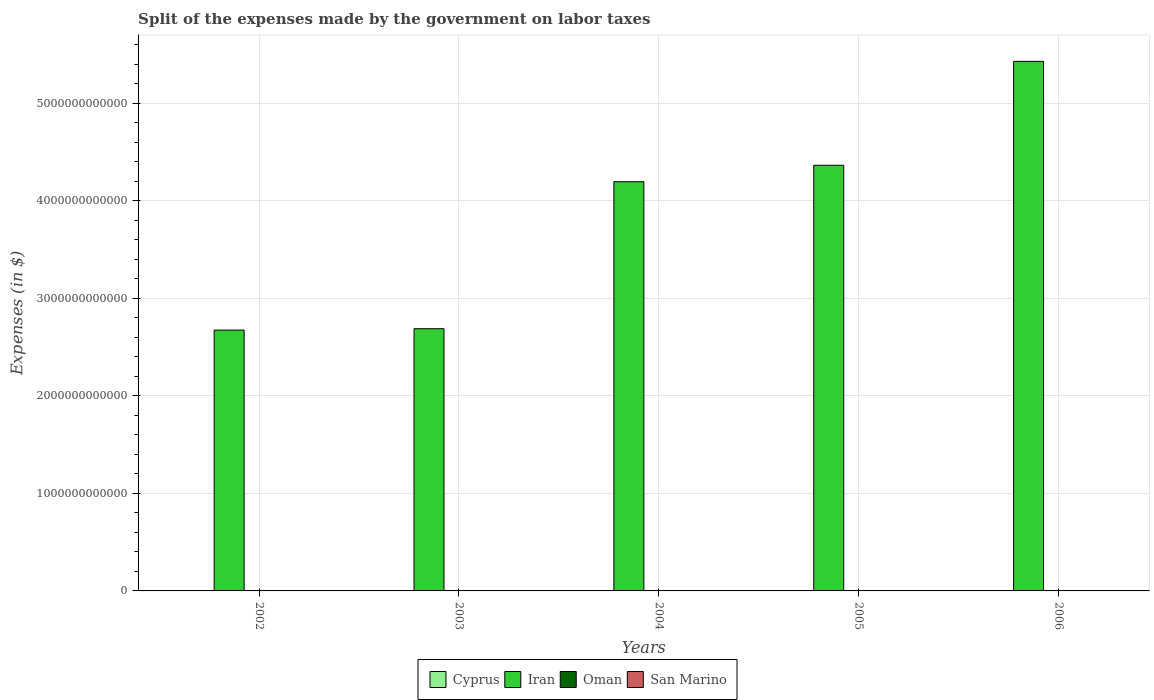How many different coloured bars are there?
Keep it short and to the point. 4. How many groups of bars are there?
Your answer should be very brief. 5. Are the number of bars per tick equal to the number of legend labels?
Offer a very short reply. Yes. Are the number of bars on each tick of the X-axis equal?
Offer a very short reply. Yes. What is the label of the 5th group of bars from the left?
Give a very brief answer. 2006. What is the expenses made by the government on labor taxes in Oman in 2002?
Keep it short and to the point. 3.98e+07. Across all years, what is the maximum expenses made by the government on labor taxes in Oman?
Provide a succinct answer. 7.82e+07. Across all years, what is the minimum expenses made by the government on labor taxes in San Marino?
Ensure brevity in your answer.  1.16e+07. What is the total expenses made by the government on labor taxes in Oman in the graph?
Your answer should be very brief. 2.81e+08. What is the difference between the expenses made by the government on labor taxes in Cyprus in 2005 and that in 2006?
Make the answer very short. 8.73e+07. What is the difference between the expenses made by the government on labor taxes in Iran in 2006 and the expenses made by the government on labor taxes in Oman in 2002?
Keep it short and to the point. 5.43e+12. What is the average expenses made by the government on labor taxes in Iran per year?
Offer a very short reply. 3.87e+12. In the year 2002, what is the difference between the expenses made by the government on labor taxes in Iran and expenses made by the government on labor taxes in Cyprus?
Provide a succinct answer. 2.67e+12. In how many years, is the expenses made by the government on labor taxes in Iran greater than 5400000000000 $?
Your answer should be very brief. 1. What is the ratio of the expenses made by the government on labor taxes in Cyprus in 2002 to that in 2005?
Provide a succinct answer. 0.25. Is the difference between the expenses made by the government on labor taxes in Iran in 2003 and 2005 greater than the difference between the expenses made by the government on labor taxes in Cyprus in 2003 and 2005?
Provide a succinct answer. No. What is the difference between the highest and the second highest expenses made by the government on labor taxes in Iran?
Provide a short and direct response. 1.07e+12. What is the difference between the highest and the lowest expenses made by the government on labor taxes in Iran?
Ensure brevity in your answer.  2.75e+12. In how many years, is the expenses made by the government on labor taxes in Oman greater than the average expenses made by the government on labor taxes in Oman taken over all years?
Make the answer very short. 2. Is the sum of the expenses made by the government on labor taxes in Iran in 2002 and 2006 greater than the maximum expenses made by the government on labor taxes in Oman across all years?
Provide a short and direct response. Yes. What does the 4th bar from the left in 2006 represents?
Offer a terse response. San Marino. What does the 4th bar from the right in 2006 represents?
Make the answer very short. Cyprus. Is it the case that in every year, the sum of the expenses made by the government on labor taxes in Oman and expenses made by the government on labor taxes in Iran is greater than the expenses made by the government on labor taxes in San Marino?
Your answer should be very brief. Yes. What is the difference between two consecutive major ticks on the Y-axis?
Keep it short and to the point. 1.00e+12. Are the values on the major ticks of Y-axis written in scientific E-notation?
Keep it short and to the point. No. How many legend labels are there?
Keep it short and to the point. 4. How are the legend labels stacked?
Ensure brevity in your answer.  Horizontal. What is the title of the graph?
Provide a succinct answer. Split of the expenses made by the government on labor taxes. What is the label or title of the X-axis?
Your response must be concise. Years. What is the label or title of the Y-axis?
Make the answer very short. Expenses (in $). What is the Expenses (in $) of Cyprus in 2002?
Ensure brevity in your answer.  1.40e+08. What is the Expenses (in $) in Iran in 2002?
Offer a very short reply. 2.67e+12. What is the Expenses (in $) of Oman in 2002?
Your answer should be compact. 3.98e+07. What is the Expenses (in $) of San Marino in 2002?
Make the answer very short. 1.16e+07. What is the Expenses (in $) of Cyprus in 2003?
Your answer should be compact. 2.93e+08. What is the Expenses (in $) of Iran in 2003?
Your answer should be very brief. 2.69e+12. What is the Expenses (in $) in Oman in 2003?
Ensure brevity in your answer.  4.31e+07. What is the Expenses (in $) in San Marino in 2003?
Provide a short and direct response. 1.21e+07. What is the Expenses (in $) of Cyprus in 2004?
Your answer should be compact. 4.89e+08. What is the Expenses (in $) in Iran in 2004?
Provide a succinct answer. 4.19e+12. What is the Expenses (in $) in Oman in 2004?
Give a very brief answer. 4.91e+07. What is the Expenses (in $) of San Marino in 2004?
Offer a terse response. 1.28e+07. What is the Expenses (in $) of Cyprus in 2005?
Offer a very short reply. 5.71e+08. What is the Expenses (in $) of Iran in 2005?
Provide a succinct answer. 4.36e+12. What is the Expenses (in $) in Oman in 2005?
Offer a terse response. 7.12e+07. What is the Expenses (in $) of San Marino in 2005?
Your response must be concise. 1.40e+07. What is the Expenses (in $) of Cyprus in 2006?
Give a very brief answer. 4.84e+08. What is the Expenses (in $) in Iran in 2006?
Your answer should be compact. 5.43e+12. What is the Expenses (in $) in Oman in 2006?
Your answer should be very brief. 7.82e+07. What is the Expenses (in $) of San Marino in 2006?
Keep it short and to the point. 2.84e+07. Across all years, what is the maximum Expenses (in $) in Cyprus?
Provide a succinct answer. 5.71e+08. Across all years, what is the maximum Expenses (in $) in Iran?
Your answer should be compact. 5.43e+12. Across all years, what is the maximum Expenses (in $) in Oman?
Offer a terse response. 7.82e+07. Across all years, what is the maximum Expenses (in $) in San Marino?
Keep it short and to the point. 2.84e+07. Across all years, what is the minimum Expenses (in $) of Cyprus?
Offer a very short reply. 1.40e+08. Across all years, what is the minimum Expenses (in $) in Iran?
Your answer should be compact. 2.67e+12. Across all years, what is the minimum Expenses (in $) in Oman?
Ensure brevity in your answer.  3.98e+07. Across all years, what is the minimum Expenses (in $) in San Marino?
Give a very brief answer. 1.16e+07. What is the total Expenses (in $) of Cyprus in the graph?
Give a very brief answer. 1.98e+09. What is the total Expenses (in $) in Iran in the graph?
Offer a very short reply. 1.93e+13. What is the total Expenses (in $) in Oman in the graph?
Ensure brevity in your answer.  2.81e+08. What is the total Expenses (in $) of San Marino in the graph?
Provide a short and direct response. 7.89e+07. What is the difference between the Expenses (in $) of Cyprus in 2002 and that in 2003?
Your response must be concise. -1.53e+08. What is the difference between the Expenses (in $) in Iran in 2002 and that in 2003?
Offer a very short reply. -1.43e+1. What is the difference between the Expenses (in $) of Oman in 2002 and that in 2003?
Offer a terse response. -3.30e+06. What is the difference between the Expenses (in $) of San Marino in 2002 and that in 2003?
Offer a very short reply. -5.42e+05. What is the difference between the Expenses (in $) of Cyprus in 2002 and that in 2004?
Offer a terse response. -3.49e+08. What is the difference between the Expenses (in $) of Iran in 2002 and that in 2004?
Provide a succinct answer. -1.52e+12. What is the difference between the Expenses (in $) of Oman in 2002 and that in 2004?
Your answer should be very brief. -9.30e+06. What is the difference between the Expenses (in $) in San Marino in 2002 and that in 2004?
Your answer should be very brief. -1.24e+06. What is the difference between the Expenses (in $) of Cyprus in 2002 and that in 2005?
Give a very brief answer. -4.30e+08. What is the difference between the Expenses (in $) of Iran in 2002 and that in 2005?
Keep it short and to the point. -1.69e+12. What is the difference between the Expenses (in $) in Oman in 2002 and that in 2005?
Make the answer very short. -3.14e+07. What is the difference between the Expenses (in $) of San Marino in 2002 and that in 2005?
Make the answer very short. -2.44e+06. What is the difference between the Expenses (in $) in Cyprus in 2002 and that in 2006?
Ensure brevity in your answer.  -3.43e+08. What is the difference between the Expenses (in $) of Iran in 2002 and that in 2006?
Your answer should be very brief. -2.75e+12. What is the difference between the Expenses (in $) of Oman in 2002 and that in 2006?
Offer a terse response. -3.84e+07. What is the difference between the Expenses (in $) of San Marino in 2002 and that in 2006?
Keep it short and to the point. -1.69e+07. What is the difference between the Expenses (in $) in Cyprus in 2003 and that in 2004?
Your response must be concise. -1.96e+08. What is the difference between the Expenses (in $) in Iran in 2003 and that in 2004?
Ensure brevity in your answer.  -1.51e+12. What is the difference between the Expenses (in $) in Oman in 2003 and that in 2004?
Your answer should be compact. -6.00e+06. What is the difference between the Expenses (in $) in San Marino in 2003 and that in 2004?
Your answer should be compact. -7.01e+05. What is the difference between the Expenses (in $) in Cyprus in 2003 and that in 2005?
Your answer should be compact. -2.77e+08. What is the difference between the Expenses (in $) in Iran in 2003 and that in 2005?
Keep it short and to the point. -1.68e+12. What is the difference between the Expenses (in $) in Oman in 2003 and that in 2005?
Your response must be concise. -2.81e+07. What is the difference between the Expenses (in $) of San Marino in 2003 and that in 2005?
Provide a succinct answer. -1.90e+06. What is the difference between the Expenses (in $) of Cyprus in 2003 and that in 2006?
Offer a terse response. -1.90e+08. What is the difference between the Expenses (in $) of Iran in 2003 and that in 2006?
Provide a succinct answer. -2.74e+12. What is the difference between the Expenses (in $) of Oman in 2003 and that in 2006?
Keep it short and to the point. -3.51e+07. What is the difference between the Expenses (in $) of San Marino in 2003 and that in 2006?
Your response must be concise. -1.63e+07. What is the difference between the Expenses (in $) of Cyprus in 2004 and that in 2005?
Make the answer very short. -8.18e+07. What is the difference between the Expenses (in $) of Iran in 2004 and that in 2005?
Offer a terse response. -1.68e+11. What is the difference between the Expenses (in $) of Oman in 2004 and that in 2005?
Keep it short and to the point. -2.21e+07. What is the difference between the Expenses (in $) in San Marino in 2004 and that in 2005?
Your answer should be very brief. -1.20e+06. What is the difference between the Expenses (in $) of Cyprus in 2004 and that in 2006?
Offer a very short reply. 5.47e+06. What is the difference between the Expenses (in $) of Iran in 2004 and that in 2006?
Your response must be concise. -1.23e+12. What is the difference between the Expenses (in $) of Oman in 2004 and that in 2006?
Provide a succinct answer. -2.91e+07. What is the difference between the Expenses (in $) of San Marino in 2004 and that in 2006?
Your answer should be very brief. -1.56e+07. What is the difference between the Expenses (in $) of Cyprus in 2005 and that in 2006?
Keep it short and to the point. 8.73e+07. What is the difference between the Expenses (in $) in Iran in 2005 and that in 2006?
Your answer should be very brief. -1.07e+12. What is the difference between the Expenses (in $) in Oman in 2005 and that in 2006?
Your response must be concise. -7.00e+06. What is the difference between the Expenses (in $) in San Marino in 2005 and that in 2006?
Provide a succinct answer. -1.44e+07. What is the difference between the Expenses (in $) in Cyprus in 2002 and the Expenses (in $) in Iran in 2003?
Offer a terse response. -2.69e+12. What is the difference between the Expenses (in $) in Cyprus in 2002 and the Expenses (in $) in Oman in 2003?
Give a very brief answer. 9.73e+07. What is the difference between the Expenses (in $) in Cyprus in 2002 and the Expenses (in $) in San Marino in 2003?
Offer a very short reply. 1.28e+08. What is the difference between the Expenses (in $) of Iran in 2002 and the Expenses (in $) of Oman in 2003?
Provide a short and direct response. 2.67e+12. What is the difference between the Expenses (in $) in Iran in 2002 and the Expenses (in $) in San Marino in 2003?
Ensure brevity in your answer.  2.67e+12. What is the difference between the Expenses (in $) of Oman in 2002 and the Expenses (in $) of San Marino in 2003?
Ensure brevity in your answer.  2.77e+07. What is the difference between the Expenses (in $) of Cyprus in 2002 and the Expenses (in $) of Iran in 2004?
Keep it short and to the point. -4.19e+12. What is the difference between the Expenses (in $) in Cyprus in 2002 and the Expenses (in $) in Oman in 2004?
Make the answer very short. 9.13e+07. What is the difference between the Expenses (in $) of Cyprus in 2002 and the Expenses (in $) of San Marino in 2004?
Your answer should be compact. 1.28e+08. What is the difference between the Expenses (in $) in Iran in 2002 and the Expenses (in $) in Oman in 2004?
Offer a very short reply. 2.67e+12. What is the difference between the Expenses (in $) in Iran in 2002 and the Expenses (in $) in San Marino in 2004?
Offer a terse response. 2.67e+12. What is the difference between the Expenses (in $) in Oman in 2002 and the Expenses (in $) in San Marino in 2004?
Your response must be concise. 2.70e+07. What is the difference between the Expenses (in $) in Cyprus in 2002 and the Expenses (in $) in Iran in 2005?
Your answer should be very brief. -4.36e+12. What is the difference between the Expenses (in $) of Cyprus in 2002 and the Expenses (in $) of Oman in 2005?
Offer a very short reply. 6.92e+07. What is the difference between the Expenses (in $) of Cyprus in 2002 and the Expenses (in $) of San Marino in 2005?
Ensure brevity in your answer.  1.26e+08. What is the difference between the Expenses (in $) in Iran in 2002 and the Expenses (in $) in Oman in 2005?
Offer a terse response. 2.67e+12. What is the difference between the Expenses (in $) in Iran in 2002 and the Expenses (in $) in San Marino in 2005?
Keep it short and to the point. 2.67e+12. What is the difference between the Expenses (in $) of Oman in 2002 and the Expenses (in $) of San Marino in 2005?
Provide a short and direct response. 2.58e+07. What is the difference between the Expenses (in $) of Cyprus in 2002 and the Expenses (in $) of Iran in 2006?
Your answer should be very brief. -5.43e+12. What is the difference between the Expenses (in $) in Cyprus in 2002 and the Expenses (in $) in Oman in 2006?
Give a very brief answer. 6.22e+07. What is the difference between the Expenses (in $) of Cyprus in 2002 and the Expenses (in $) of San Marino in 2006?
Offer a terse response. 1.12e+08. What is the difference between the Expenses (in $) of Iran in 2002 and the Expenses (in $) of Oman in 2006?
Your response must be concise. 2.67e+12. What is the difference between the Expenses (in $) in Iran in 2002 and the Expenses (in $) in San Marino in 2006?
Your answer should be compact. 2.67e+12. What is the difference between the Expenses (in $) of Oman in 2002 and the Expenses (in $) of San Marino in 2006?
Keep it short and to the point. 1.14e+07. What is the difference between the Expenses (in $) of Cyprus in 2003 and the Expenses (in $) of Iran in 2004?
Provide a succinct answer. -4.19e+12. What is the difference between the Expenses (in $) in Cyprus in 2003 and the Expenses (in $) in Oman in 2004?
Your response must be concise. 2.44e+08. What is the difference between the Expenses (in $) in Cyprus in 2003 and the Expenses (in $) in San Marino in 2004?
Your response must be concise. 2.81e+08. What is the difference between the Expenses (in $) of Iran in 2003 and the Expenses (in $) of Oman in 2004?
Ensure brevity in your answer.  2.69e+12. What is the difference between the Expenses (in $) of Iran in 2003 and the Expenses (in $) of San Marino in 2004?
Keep it short and to the point. 2.69e+12. What is the difference between the Expenses (in $) in Oman in 2003 and the Expenses (in $) in San Marino in 2004?
Make the answer very short. 3.03e+07. What is the difference between the Expenses (in $) in Cyprus in 2003 and the Expenses (in $) in Iran in 2005?
Offer a terse response. -4.36e+12. What is the difference between the Expenses (in $) in Cyprus in 2003 and the Expenses (in $) in Oman in 2005?
Your answer should be compact. 2.22e+08. What is the difference between the Expenses (in $) in Cyprus in 2003 and the Expenses (in $) in San Marino in 2005?
Ensure brevity in your answer.  2.79e+08. What is the difference between the Expenses (in $) in Iran in 2003 and the Expenses (in $) in Oman in 2005?
Offer a very short reply. 2.69e+12. What is the difference between the Expenses (in $) of Iran in 2003 and the Expenses (in $) of San Marino in 2005?
Offer a terse response. 2.69e+12. What is the difference between the Expenses (in $) in Oman in 2003 and the Expenses (in $) in San Marino in 2005?
Offer a terse response. 2.91e+07. What is the difference between the Expenses (in $) in Cyprus in 2003 and the Expenses (in $) in Iran in 2006?
Offer a terse response. -5.43e+12. What is the difference between the Expenses (in $) in Cyprus in 2003 and the Expenses (in $) in Oman in 2006?
Provide a short and direct response. 2.15e+08. What is the difference between the Expenses (in $) of Cyprus in 2003 and the Expenses (in $) of San Marino in 2006?
Provide a short and direct response. 2.65e+08. What is the difference between the Expenses (in $) of Iran in 2003 and the Expenses (in $) of Oman in 2006?
Ensure brevity in your answer.  2.69e+12. What is the difference between the Expenses (in $) of Iran in 2003 and the Expenses (in $) of San Marino in 2006?
Offer a very short reply. 2.69e+12. What is the difference between the Expenses (in $) of Oman in 2003 and the Expenses (in $) of San Marino in 2006?
Provide a short and direct response. 1.47e+07. What is the difference between the Expenses (in $) in Cyprus in 2004 and the Expenses (in $) in Iran in 2005?
Make the answer very short. -4.36e+12. What is the difference between the Expenses (in $) of Cyprus in 2004 and the Expenses (in $) of Oman in 2005?
Make the answer very short. 4.18e+08. What is the difference between the Expenses (in $) of Cyprus in 2004 and the Expenses (in $) of San Marino in 2005?
Ensure brevity in your answer.  4.75e+08. What is the difference between the Expenses (in $) of Iran in 2004 and the Expenses (in $) of Oman in 2005?
Make the answer very short. 4.19e+12. What is the difference between the Expenses (in $) of Iran in 2004 and the Expenses (in $) of San Marino in 2005?
Your answer should be very brief. 4.19e+12. What is the difference between the Expenses (in $) of Oman in 2004 and the Expenses (in $) of San Marino in 2005?
Offer a very short reply. 3.51e+07. What is the difference between the Expenses (in $) of Cyprus in 2004 and the Expenses (in $) of Iran in 2006?
Make the answer very short. -5.43e+12. What is the difference between the Expenses (in $) of Cyprus in 2004 and the Expenses (in $) of Oman in 2006?
Keep it short and to the point. 4.11e+08. What is the difference between the Expenses (in $) in Cyprus in 2004 and the Expenses (in $) in San Marino in 2006?
Ensure brevity in your answer.  4.61e+08. What is the difference between the Expenses (in $) of Iran in 2004 and the Expenses (in $) of Oman in 2006?
Provide a succinct answer. 4.19e+12. What is the difference between the Expenses (in $) of Iran in 2004 and the Expenses (in $) of San Marino in 2006?
Your answer should be very brief. 4.19e+12. What is the difference between the Expenses (in $) in Oman in 2004 and the Expenses (in $) in San Marino in 2006?
Your response must be concise. 2.07e+07. What is the difference between the Expenses (in $) of Cyprus in 2005 and the Expenses (in $) of Iran in 2006?
Offer a very short reply. -5.43e+12. What is the difference between the Expenses (in $) in Cyprus in 2005 and the Expenses (in $) in Oman in 2006?
Keep it short and to the point. 4.93e+08. What is the difference between the Expenses (in $) in Cyprus in 2005 and the Expenses (in $) in San Marino in 2006?
Give a very brief answer. 5.42e+08. What is the difference between the Expenses (in $) of Iran in 2005 and the Expenses (in $) of Oman in 2006?
Provide a succinct answer. 4.36e+12. What is the difference between the Expenses (in $) of Iran in 2005 and the Expenses (in $) of San Marino in 2006?
Offer a very short reply. 4.36e+12. What is the difference between the Expenses (in $) in Oman in 2005 and the Expenses (in $) in San Marino in 2006?
Keep it short and to the point. 4.28e+07. What is the average Expenses (in $) in Cyprus per year?
Provide a short and direct response. 3.95e+08. What is the average Expenses (in $) of Iran per year?
Keep it short and to the point. 3.87e+12. What is the average Expenses (in $) in Oman per year?
Keep it short and to the point. 5.63e+07. What is the average Expenses (in $) in San Marino per year?
Provide a short and direct response. 1.58e+07. In the year 2002, what is the difference between the Expenses (in $) in Cyprus and Expenses (in $) in Iran?
Ensure brevity in your answer.  -2.67e+12. In the year 2002, what is the difference between the Expenses (in $) in Cyprus and Expenses (in $) in Oman?
Provide a succinct answer. 1.01e+08. In the year 2002, what is the difference between the Expenses (in $) of Cyprus and Expenses (in $) of San Marino?
Your answer should be very brief. 1.29e+08. In the year 2002, what is the difference between the Expenses (in $) of Iran and Expenses (in $) of Oman?
Make the answer very short. 2.67e+12. In the year 2002, what is the difference between the Expenses (in $) in Iran and Expenses (in $) in San Marino?
Make the answer very short. 2.67e+12. In the year 2002, what is the difference between the Expenses (in $) of Oman and Expenses (in $) of San Marino?
Ensure brevity in your answer.  2.82e+07. In the year 2003, what is the difference between the Expenses (in $) of Cyprus and Expenses (in $) of Iran?
Your answer should be very brief. -2.69e+12. In the year 2003, what is the difference between the Expenses (in $) in Cyprus and Expenses (in $) in Oman?
Your answer should be compact. 2.50e+08. In the year 2003, what is the difference between the Expenses (in $) in Cyprus and Expenses (in $) in San Marino?
Your response must be concise. 2.81e+08. In the year 2003, what is the difference between the Expenses (in $) of Iran and Expenses (in $) of Oman?
Ensure brevity in your answer.  2.69e+12. In the year 2003, what is the difference between the Expenses (in $) of Iran and Expenses (in $) of San Marino?
Provide a succinct answer. 2.69e+12. In the year 2003, what is the difference between the Expenses (in $) of Oman and Expenses (in $) of San Marino?
Your answer should be very brief. 3.10e+07. In the year 2004, what is the difference between the Expenses (in $) of Cyprus and Expenses (in $) of Iran?
Your response must be concise. -4.19e+12. In the year 2004, what is the difference between the Expenses (in $) in Cyprus and Expenses (in $) in Oman?
Provide a succinct answer. 4.40e+08. In the year 2004, what is the difference between the Expenses (in $) of Cyprus and Expenses (in $) of San Marino?
Provide a succinct answer. 4.76e+08. In the year 2004, what is the difference between the Expenses (in $) in Iran and Expenses (in $) in Oman?
Your answer should be compact. 4.19e+12. In the year 2004, what is the difference between the Expenses (in $) of Iran and Expenses (in $) of San Marino?
Provide a short and direct response. 4.19e+12. In the year 2004, what is the difference between the Expenses (in $) in Oman and Expenses (in $) in San Marino?
Keep it short and to the point. 3.63e+07. In the year 2005, what is the difference between the Expenses (in $) of Cyprus and Expenses (in $) of Iran?
Provide a succinct answer. -4.36e+12. In the year 2005, what is the difference between the Expenses (in $) in Cyprus and Expenses (in $) in Oman?
Provide a succinct answer. 5.00e+08. In the year 2005, what is the difference between the Expenses (in $) of Cyprus and Expenses (in $) of San Marino?
Keep it short and to the point. 5.57e+08. In the year 2005, what is the difference between the Expenses (in $) in Iran and Expenses (in $) in Oman?
Provide a short and direct response. 4.36e+12. In the year 2005, what is the difference between the Expenses (in $) in Iran and Expenses (in $) in San Marino?
Your response must be concise. 4.36e+12. In the year 2005, what is the difference between the Expenses (in $) in Oman and Expenses (in $) in San Marino?
Give a very brief answer. 5.72e+07. In the year 2006, what is the difference between the Expenses (in $) of Cyprus and Expenses (in $) of Iran?
Your answer should be compact. -5.43e+12. In the year 2006, what is the difference between the Expenses (in $) of Cyprus and Expenses (in $) of Oman?
Keep it short and to the point. 4.05e+08. In the year 2006, what is the difference between the Expenses (in $) of Cyprus and Expenses (in $) of San Marino?
Provide a short and direct response. 4.55e+08. In the year 2006, what is the difference between the Expenses (in $) of Iran and Expenses (in $) of Oman?
Your response must be concise. 5.43e+12. In the year 2006, what is the difference between the Expenses (in $) in Iran and Expenses (in $) in San Marino?
Ensure brevity in your answer.  5.43e+12. In the year 2006, what is the difference between the Expenses (in $) of Oman and Expenses (in $) of San Marino?
Provide a succinct answer. 4.98e+07. What is the ratio of the Expenses (in $) in Cyprus in 2002 to that in 2003?
Offer a very short reply. 0.48. What is the ratio of the Expenses (in $) in Oman in 2002 to that in 2003?
Offer a very short reply. 0.92. What is the ratio of the Expenses (in $) of San Marino in 2002 to that in 2003?
Your answer should be compact. 0.96. What is the ratio of the Expenses (in $) in Cyprus in 2002 to that in 2004?
Ensure brevity in your answer.  0.29. What is the ratio of the Expenses (in $) of Iran in 2002 to that in 2004?
Ensure brevity in your answer.  0.64. What is the ratio of the Expenses (in $) in Oman in 2002 to that in 2004?
Offer a very short reply. 0.81. What is the ratio of the Expenses (in $) in San Marino in 2002 to that in 2004?
Your response must be concise. 0.9. What is the ratio of the Expenses (in $) in Cyprus in 2002 to that in 2005?
Ensure brevity in your answer.  0.25. What is the ratio of the Expenses (in $) in Iran in 2002 to that in 2005?
Offer a terse response. 0.61. What is the ratio of the Expenses (in $) of Oman in 2002 to that in 2005?
Provide a succinct answer. 0.56. What is the ratio of the Expenses (in $) of San Marino in 2002 to that in 2005?
Your response must be concise. 0.83. What is the ratio of the Expenses (in $) in Cyprus in 2002 to that in 2006?
Provide a short and direct response. 0.29. What is the ratio of the Expenses (in $) of Iran in 2002 to that in 2006?
Offer a very short reply. 0.49. What is the ratio of the Expenses (in $) in Oman in 2002 to that in 2006?
Your answer should be very brief. 0.51. What is the ratio of the Expenses (in $) of San Marino in 2002 to that in 2006?
Your answer should be compact. 0.41. What is the ratio of the Expenses (in $) in Cyprus in 2003 to that in 2004?
Your answer should be compact. 0.6. What is the ratio of the Expenses (in $) of Iran in 2003 to that in 2004?
Provide a succinct answer. 0.64. What is the ratio of the Expenses (in $) of Oman in 2003 to that in 2004?
Give a very brief answer. 0.88. What is the ratio of the Expenses (in $) of San Marino in 2003 to that in 2004?
Your response must be concise. 0.95. What is the ratio of the Expenses (in $) of Cyprus in 2003 to that in 2005?
Provide a short and direct response. 0.51. What is the ratio of the Expenses (in $) of Iran in 2003 to that in 2005?
Your answer should be compact. 0.62. What is the ratio of the Expenses (in $) of Oman in 2003 to that in 2005?
Provide a succinct answer. 0.61. What is the ratio of the Expenses (in $) of San Marino in 2003 to that in 2005?
Provide a short and direct response. 0.86. What is the ratio of the Expenses (in $) in Cyprus in 2003 to that in 2006?
Provide a succinct answer. 0.61. What is the ratio of the Expenses (in $) of Iran in 2003 to that in 2006?
Make the answer very short. 0.5. What is the ratio of the Expenses (in $) of Oman in 2003 to that in 2006?
Make the answer very short. 0.55. What is the ratio of the Expenses (in $) of San Marino in 2003 to that in 2006?
Your answer should be compact. 0.43. What is the ratio of the Expenses (in $) of Cyprus in 2004 to that in 2005?
Give a very brief answer. 0.86. What is the ratio of the Expenses (in $) of Iran in 2004 to that in 2005?
Your response must be concise. 0.96. What is the ratio of the Expenses (in $) of Oman in 2004 to that in 2005?
Make the answer very short. 0.69. What is the ratio of the Expenses (in $) of San Marino in 2004 to that in 2005?
Provide a short and direct response. 0.91. What is the ratio of the Expenses (in $) of Cyprus in 2004 to that in 2006?
Your answer should be compact. 1.01. What is the ratio of the Expenses (in $) of Iran in 2004 to that in 2006?
Ensure brevity in your answer.  0.77. What is the ratio of the Expenses (in $) of Oman in 2004 to that in 2006?
Ensure brevity in your answer.  0.63. What is the ratio of the Expenses (in $) in San Marino in 2004 to that in 2006?
Ensure brevity in your answer.  0.45. What is the ratio of the Expenses (in $) in Cyprus in 2005 to that in 2006?
Make the answer very short. 1.18. What is the ratio of the Expenses (in $) in Iran in 2005 to that in 2006?
Offer a very short reply. 0.8. What is the ratio of the Expenses (in $) in Oman in 2005 to that in 2006?
Your answer should be very brief. 0.91. What is the ratio of the Expenses (in $) in San Marino in 2005 to that in 2006?
Your answer should be very brief. 0.49. What is the difference between the highest and the second highest Expenses (in $) of Cyprus?
Provide a short and direct response. 8.18e+07. What is the difference between the highest and the second highest Expenses (in $) of Iran?
Offer a terse response. 1.07e+12. What is the difference between the highest and the second highest Expenses (in $) of Oman?
Offer a very short reply. 7.00e+06. What is the difference between the highest and the second highest Expenses (in $) of San Marino?
Ensure brevity in your answer.  1.44e+07. What is the difference between the highest and the lowest Expenses (in $) of Cyprus?
Offer a terse response. 4.30e+08. What is the difference between the highest and the lowest Expenses (in $) in Iran?
Offer a terse response. 2.75e+12. What is the difference between the highest and the lowest Expenses (in $) in Oman?
Offer a very short reply. 3.84e+07. What is the difference between the highest and the lowest Expenses (in $) in San Marino?
Your answer should be compact. 1.69e+07. 